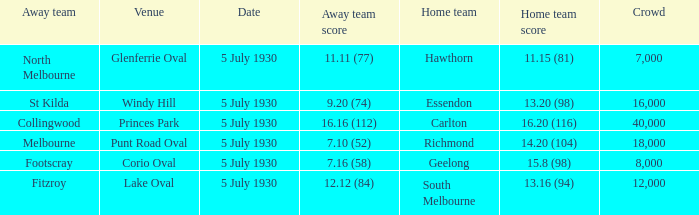Who is the away side at corio oval? Footscray. 